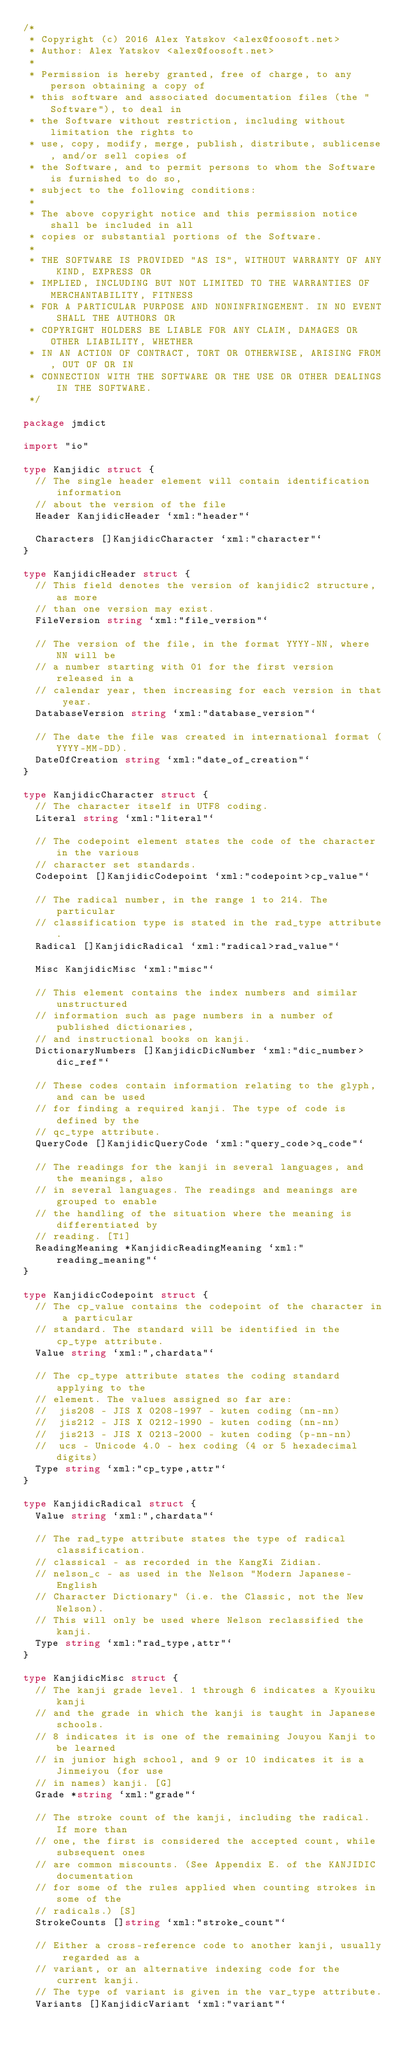<code> <loc_0><loc_0><loc_500><loc_500><_Go_>/*
 * Copyright (c) 2016 Alex Yatskov <alex@foosoft.net>
 * Author: Alex Yatskov <alex@foosoft.net>
 *
 * Permission is hereby granted, free of charge, to any person obtaining a copy of
 * this software and associated documentation files (the "Software"), to deal in
 * the Software without restriction, including without limitation the rights to
 * use, copy, modify, merge, publish, distribute, sublicense, and/or sell copies of
 * the Software, and to permit persons to whom the Software is furnished to do so,
 * subject to the following conditions:
 *
 * The above copyright notice and this permission notice shall be included in all
 * copies or substantial portions of the Software.
 *
 * THE SOFTWARE IS PROVIDED "AS IS", WITHOUT WARRANTY OF ANY KIND, EXPRESS OR
 * IMPLIED, INCLUDING BUT NOT LIMITED TO THE WARRANTIES OF MERCHANTABILITY, FITNESS
 * FOR A PARTICULAR PURPOSE AND NONINFRINGEMENT. IN NO EVENT SHALL THE AUTHORS OR
 * COPYRIGHT HOLDERS BE LIABLE FOR ANY CLAIM, DAMAGES OR OTHER LIABILITY, WHETHER
 * IN AN ACTION OF CONTRACT, TORT OR OTHERWISE, ARISING FROM, OUT OF OR IN
 * CONNECTION WITH THE SOFTWARE OR THE USE OR OTHER DEALINGS IN THE SOFTWARE.
 */

package jmdict

import "io"

type Kanjidic struct {
	// The single header element will contain identification information
	// about the version of the file
	Header KanjidicHeader `xml:"header"`

	Characters []KanjidicCharacter `xml:"character"`
}

type KanjidicHeader struct {
	// This field denotes the version of kanjidic2 structure, as more
	// than one version may exist.
	FileVersion string `xml:"file_version"`

	// The version of the file, in the format YYYY-NN, where NN will be
	// a number starting with 01 for the first version released in a
	// calendar year, then increasing for each version in that year.
	DatabaseVersion string `xml:"database_version"`

	// The date the file was created in international format (YYYY-MM-DD).
	DateOfCreation string `xml:"date_of_creation"`
}

type KanjidicCharacter struct {
	// The character itself in UTF8 coding.
	Literal string `xml:"literal"`

	// The codepoint element states the code of the character in the various
	// character set standards.
	Codepoint []KanjidicCodepoint `xml:"codepoint>cp_value"`

	// The radical number, in the range 1 to 214. The particular
	// classification type is stated in the rad_type attribute.
	Radical []KanjidicRadical `xml:"radical>rad_value"`

	Misc KanjidicMisc `xml:"misc"`

	// This element contains the index numbers and similar unstructured
	// information such as page numbers in a number of published dictionaries,
	// and instructional books on kanji.
	DictionaryNumbers []KanjidicDicNumber `xml:"dic_number>dic_ref"`

	// These codes contain information relating to the glyph, and can be used
	// for finding a required kanji. The type of code is defined by the
	// qc_type attribute.
	QueryCode []KanjidicQueryCode `xml:"query_code>q_code"`

	// The readings for the kanji in several languages, and the meanings, also
	// in several languages. The readings and meanings are grouped to enable
	// the handling of the situation where the meaning is differentiated by
	// reading. [T1]
	ReadingMeaning *KanjidicReadingMeaning `xml:"reading_meaning"`
}

type KanjidicCodepoint struct {
	// The cp_value contains the codepoint of the character in a particular
	// standard. The standard will be identified in the cp_type attribute.
	Value string `xml:",chardata"`

	// The cp_type attribute states the coding standard applying to the
	// element. The values assigned so far are:
	// 	jis208 - JIS X 0208-1997 - kuten coding (nn-nn)
	// 	jis212 - JIS X 0212-1990 - kuten coding (nn-nn)
	// 	jis213 - JIS X 0213-2000 - kuten coding (p-nn-nn)
	// 	ucs - Unicode 4.0 - hex coding (4 or 5 hexadecimal digits)
	Type string `xml:"cp_type,attr"`
}

type KanjidicRadical struct {
	Value string `xml:",chardata"`

	// The rad_type attribute states the type of radical classification.
	// classical - as recorded in the KangXi Zidian.
	// nelson_c - as used in the Nelson "Modern Japanese-English
	// Character Dictionary" (i.e. the Classic, not the New Nelson).
	// This will only be used where Nelson reclassified the kanji.
	Type string `xml:"rad_type,attr"`
}

type KanjidicMisc struct {
	// The kanji grade level. 1 through 6 indicates a Kyouiku kanji
	// and the grade in which the kanji is taught in Japanese schools.
	// 8 indicates it is one of the remaining Jouyou Kanji to be learned
	// in junior high school, and 9 or 10 indicates it is a Jinmeiyou (for use
	// in names) kanji. [G]
	Grade *string `xml:"grade"`

	// The stroke count of the kanji, including the radical. If more than
	// one, the first is considered the accepted count, while subsequent ones
	// are common miscounts. (See Appendix E. of the KANJIDIC documentation
	// for some of the rules applied when counting strokes in some of the
	// radicals.) [S]
	StrokeCounts []string `xml:"stroke_count"`

	// Either a cross-reference code to another kanji, usually regarded as a
	// variant, or an alternative indexing code for the current kanji.
	// The type of variant is given in the var_type attribute.
	Variants []KanjidicVariant `xml:"variant"`
</code> 